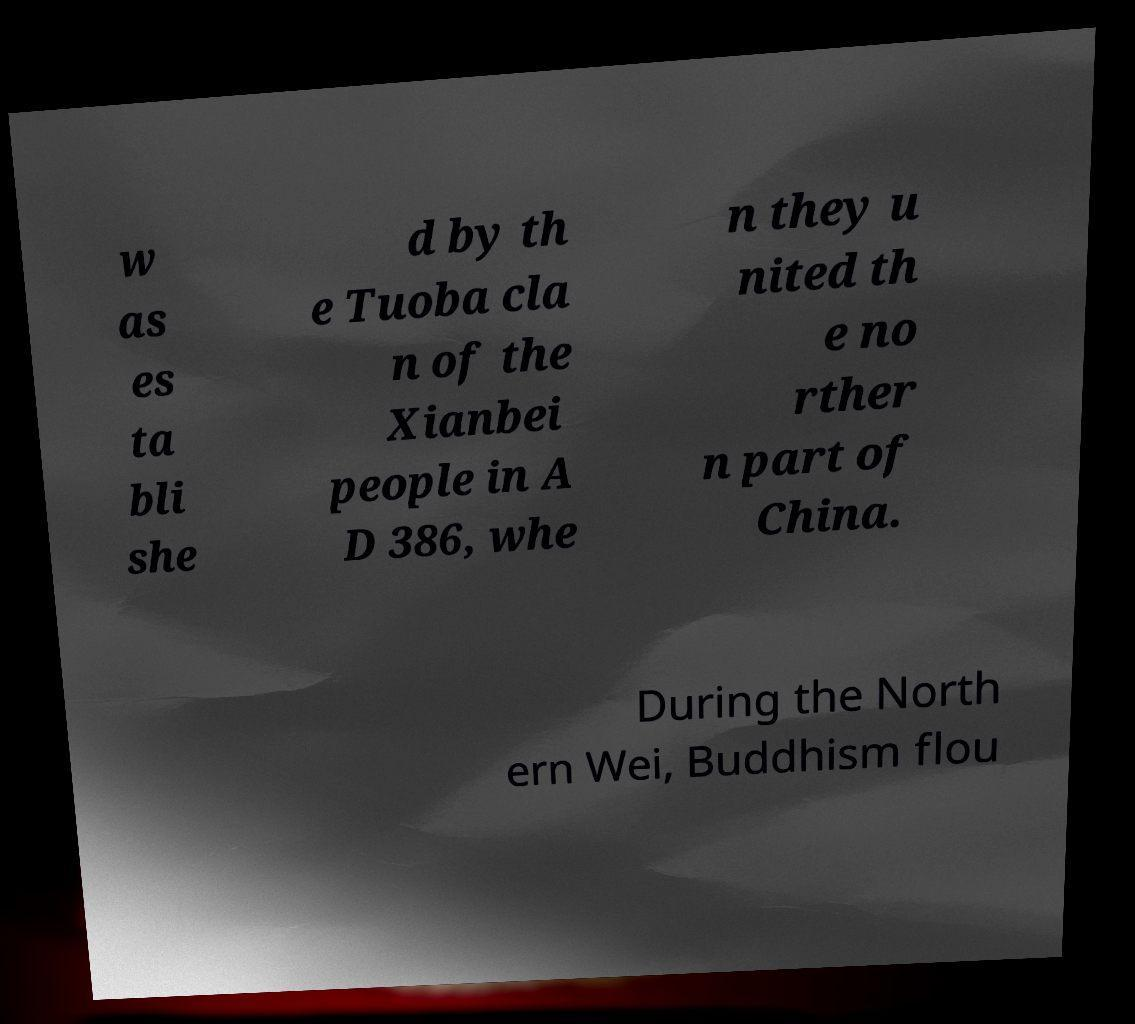Please identify and transcribe the text found in this image. w as es ta bli she d by th e Tuoba cla n of the Xianbei people in A D 386, whe n they u nited th e no rther n part of China. During the North ern Wei, Buddhism flou 